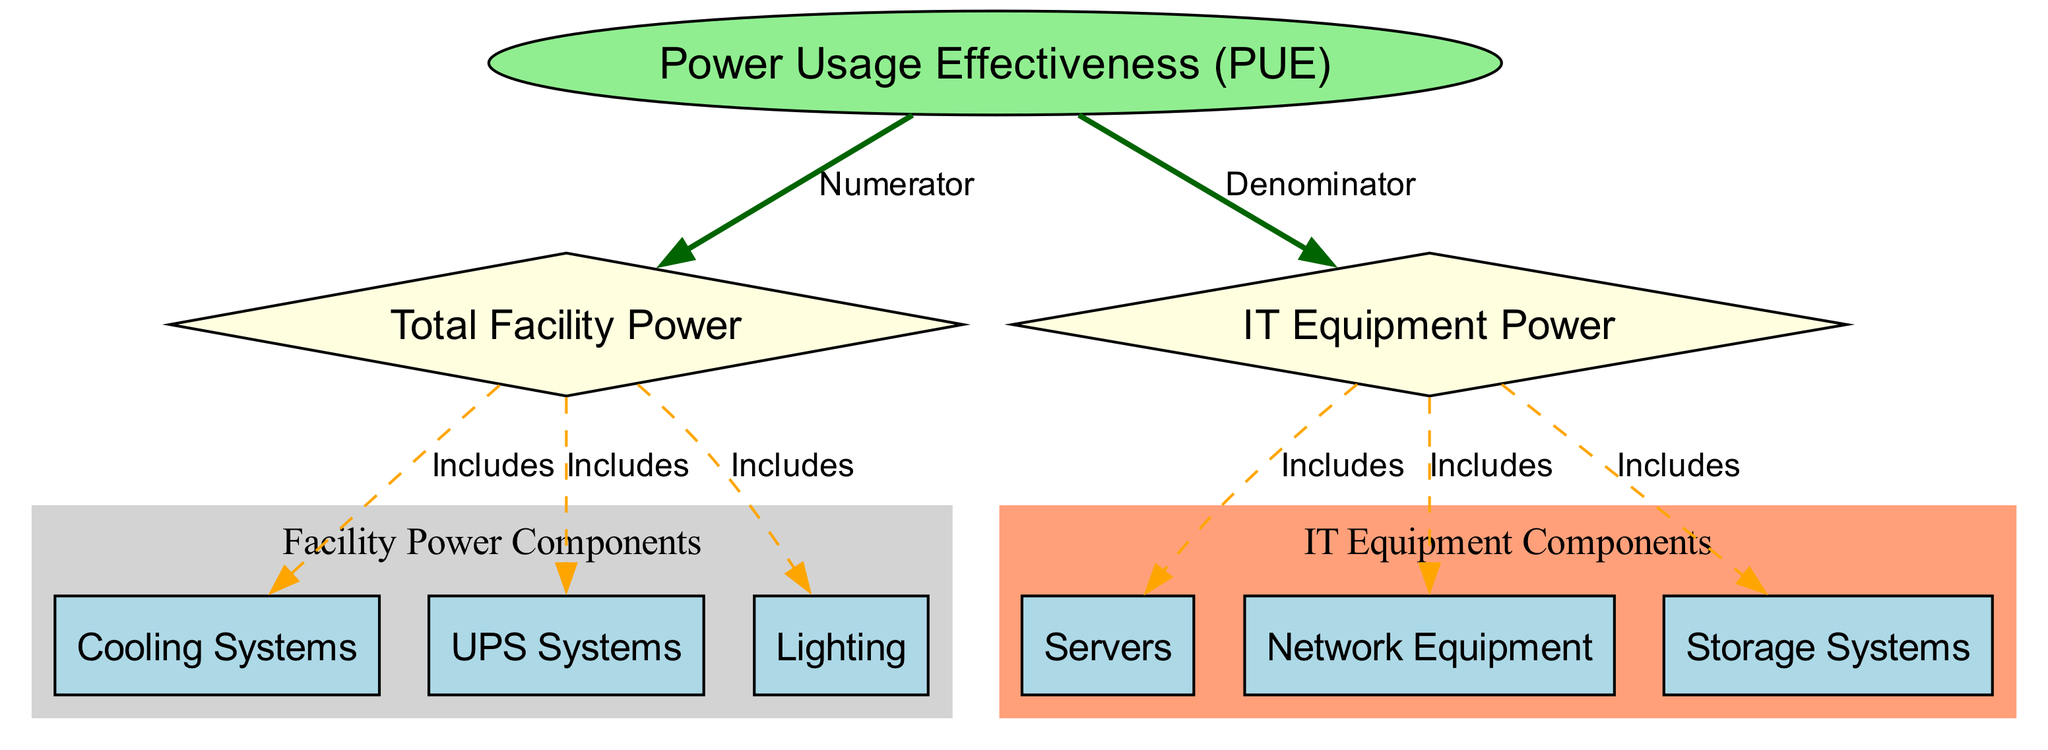What is the label of the main concept represented by the central node? The central node is labeled 'Power Usage Effectiveness (PUE)', as indicated in the diagram where it is visually distinct and is the starting point of the flows.
Answer: Power Usage Effectiveness (PUE) How many edges are connected to the 'Total Facility Power' node? The 'Total Facility Power' node has three edges connecting to the 'Cooling Systems', 'UPS Systems', and 'Lighting', which are indicated as direct inclusions based on the diagram's relationships.
Answer: 3 Which node represents the denominator in the PUE calculation? The node labeled 'IT Equipment Power' is connected to the main node as the denominator in the equation, highlighting its role in calculating PUE.
Answer: IT Equipment Power What type of graph structure is used to represent the breakdown of PUE? The structure employed in this diagram is a directed graph, as seen from the arrows indicating the direction of relationships between the nodes.
Answer: Directed graph Which category do 'Cooling Systems' and 'UPS Systems' belong to in the diagram? Both 'Cooling Systems' and 'UPS Systems' are included under the 'Facility Power Components' subgraph, indicated by their grouping within a shaded area in the visual representation.
Answer: Facility Power Components What element is included in the 'IT Equipment Power'? The 'Servers' node is one of several components included within the 'IT Equipment Power', as shown by its direct edge connection.
Answer: Servers How does the 'Power Usage Effectiveness (PUE)' relate to 'Total Facility Power'? The relationship is defined as the numerator of the PUE calculation, indicating that the 'Total Facility Power' provides the total input required for the effectiveness calculation.
Answer: Numerator Which node has a different shape than the others in the diagram? The 'Power Usage Effectiveness (PUE)' node is shaped as an ellipse, which sets it apart visually from the diamond-shaped nodes representing 'Total Facility Power' and 'IT Equipment Power'.
Answer: Power Usage Effectiveness (PUE) What overall conclusion can be drawn based on the contents of IT Equipment Power? The contents collectively consist of all essential IT systems—'Servers', 'Network Equipment', and 'Storage Systems', as denoted through their inclusive relationships connecting back to 'IT Equipment Power'.
Answer: Servers, Network Equipment, Storage Systems 